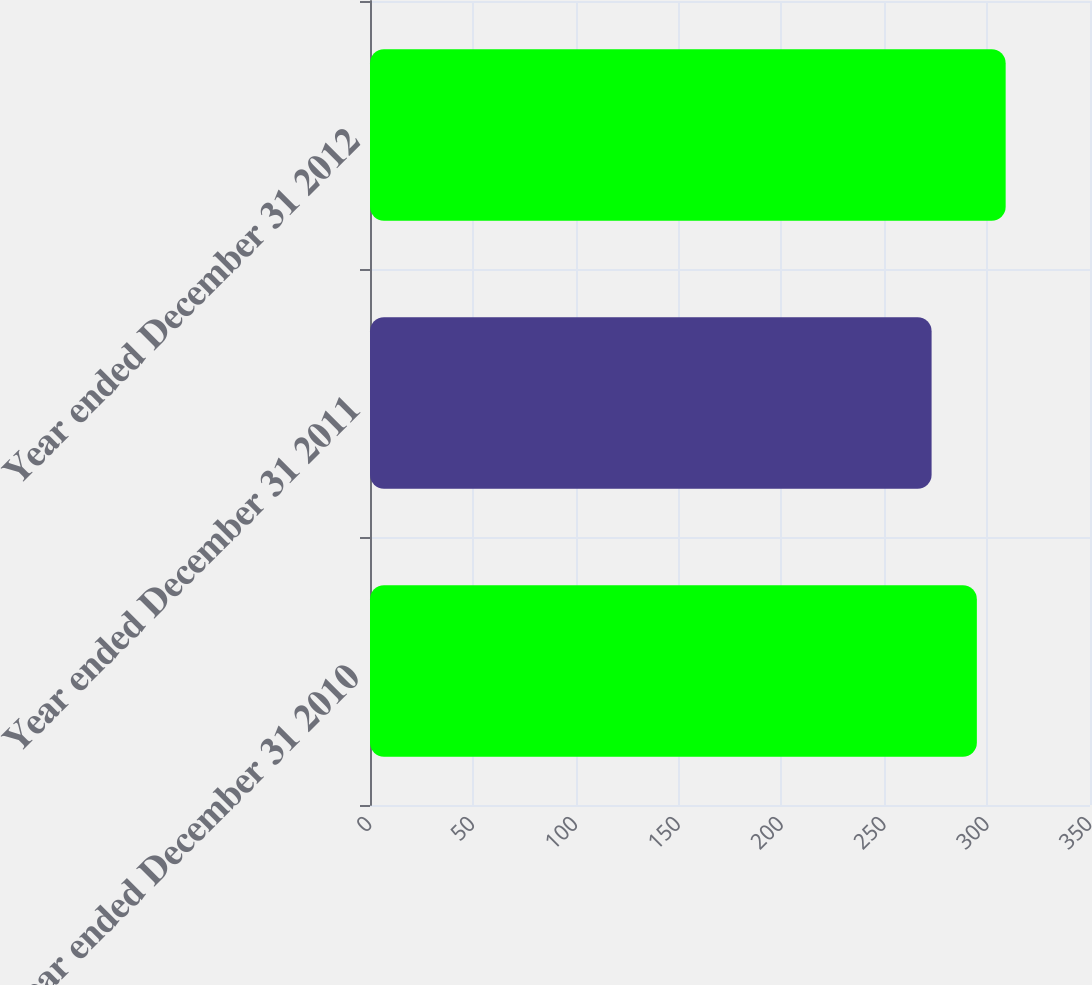<chart> <loc_0><loc_0><loc_500><loc_500><bar_chart><fcel>Year ended December 31 2010<fcel>Year ended December 31 2011<fcel>Year ended December 31 2012<nl><fcel>295<fcel>273<fcel>309<nl></chart> 